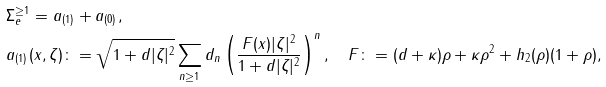Convert formula to latex. <formula><loc_0><loc_0><loc_500><loc_500>& \Sigma _ { e } ^ { \geq 1 } = a _ { ( 1 ) } + a _ { ( 0 ) } , \\ & a _ { ( 1 ) } ( x , \zeta ) \colon = \sqrt { 1 + d | \zeta | ^ { 2 } } \sum _ { n \geq 1 } d _ { n } \left ( \frac { F ( x ) | \zeta | ^ { 2 } } { 1 + d | \zeta | ^ { 2 } } \right ) ^ { n } , \quad F \colon = ( d + \kappa ) \rho + \kappa \rho ^ { 2 } + h _ { 2 } ( \rho ) ( 1 + \rho ) ,</formula> 